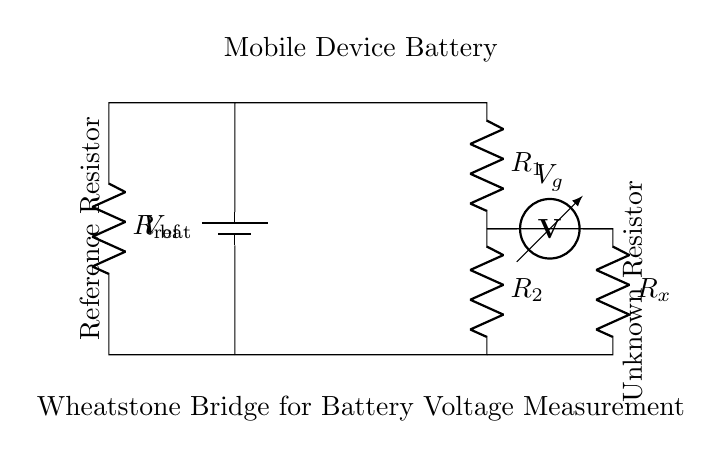What type of circuit is shown? The circuit depicted is a Wheatstone bridge, which is used for precisely measuring resistance and voltage. It consists of a network of resistors in a rhombus formation with a galvanometer.
Answer: Wheatstone bridge What is the battery voltage labeled as? The battery voltage in this circuit is labeled as V bat, indicating the source voltage supplied by the mobile device battery.
Answer: V bat What is the role of the reference resistor? The reference resistor, labeled R ref, is used to provide a known resistance value against which the unknown resistor can be compared to determine the voltage across it.
Answer: Measure known resistance What is the purpose of voltmeter in this circuit? The voltmeter, labeled V g, measures the voltage across the unknown resistor, allowing for the precise calculation of the unknown resistor's value using the bridge principle.
Answer: Measure unknown voltage How many resistors are present in the circuit? There are four resistors in the Wheatstone bridge: R 1, R 2, R ref, and R x, which include both the known and unknown resistances.
Answer: Four resistors What happens when the bridge is balanced? When the bridge is balanced, no current flows through the galvanometer (voltmeter) and the ratio of the resistances allows for accurate measurement of the unknown resistor.
Answer: Zero current through voltmeter What does the term R x signify in this circuit? R x represents the unknown resistance that is being measured in the circuit, and its value can be calculated based on the voltage measured and known resistances.
Answer: Unknown resistance 